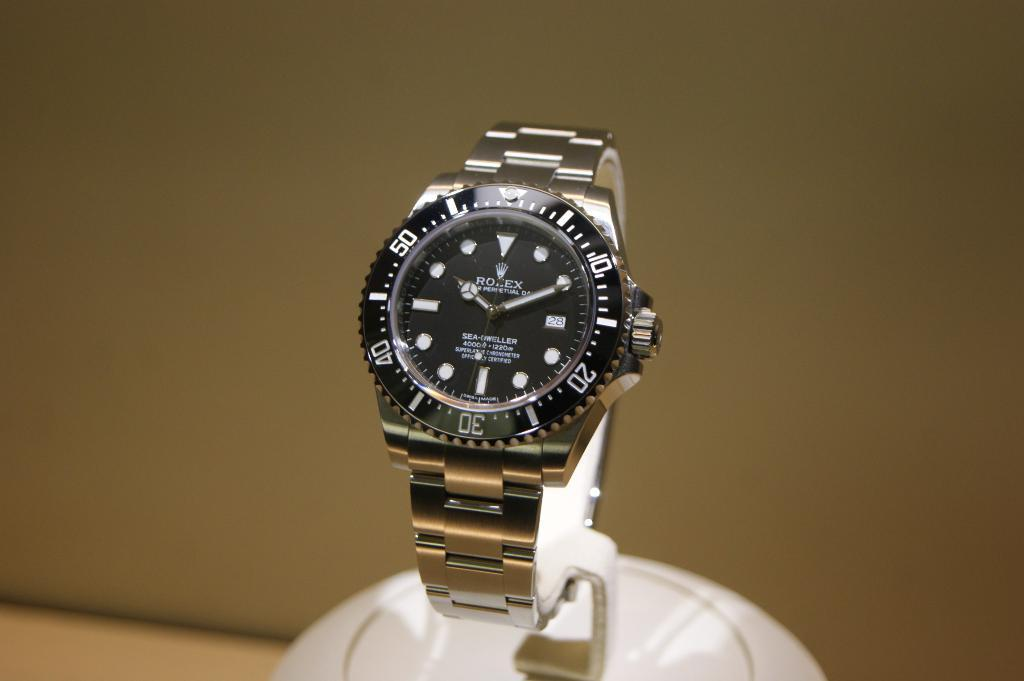<image>
Summarize the visual content of the image. A displayed Rolex watch shows the time of 10:11. 